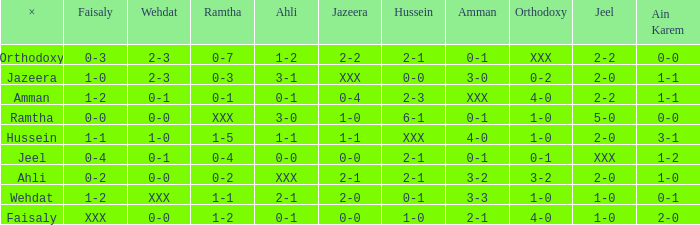What is ahli when ramtha is 0-4? 0-0. 